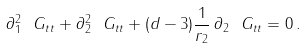<formula> <loc_0><loc_0><loc_500><loc_500>\partial _ { 1 } ^ { 2 } \ G _ { t t } + \partial _ { 2 } ^ { 2 } \ G _ { t t } + ( d - 3 ) \frac { 1 } { r _ { 2 } } \, \partial _ { 2 } \ G _ { t t } = 0 \, .</formula> 